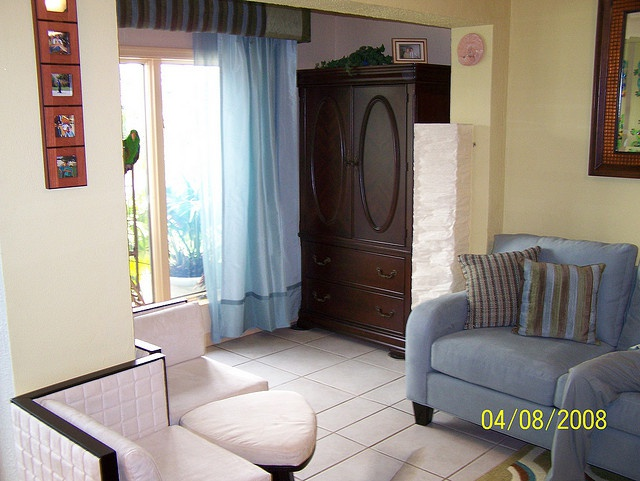Describe the objects in this image and their specific colors. I can see couch in tan, gray, darkgray, and black tones, couch in tan, lightgray, darkgray, and black tones, chair in tan, lightgray, and darkgray tones, chair in tan, darkgray, and lightgray tones, and people in tan, gray, black, and yellow tones in this image. 